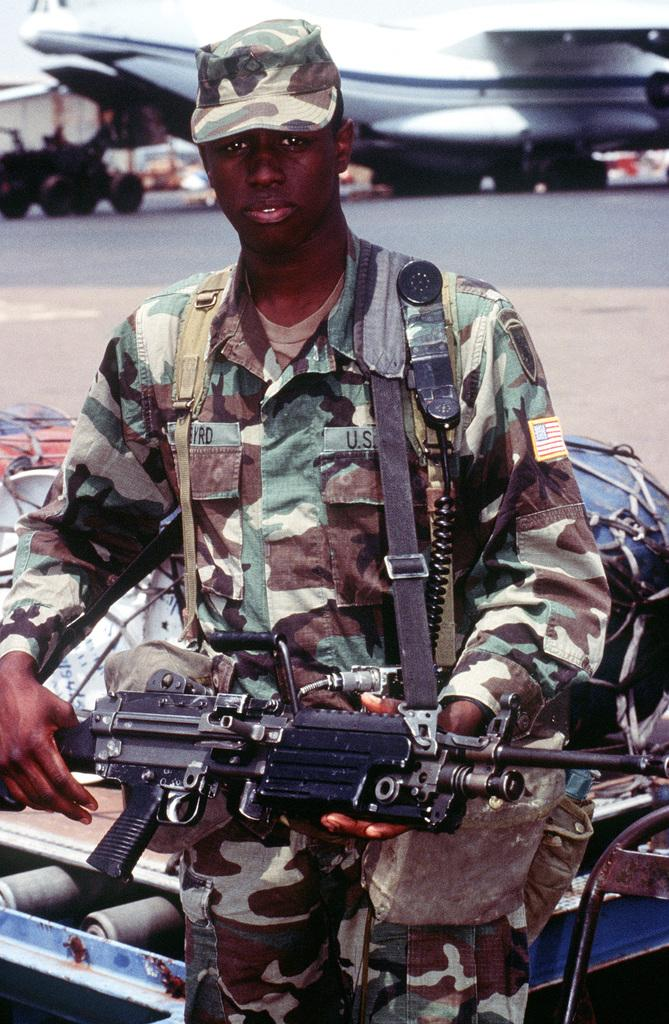What is the main subject of the image? There is a soldier in the image. What is the soldier holding in the image? The soldier is holding a gun. What is the soldier's posture in the image? The soldier is standing. What can be seen behind the soldier in the image? There are objects behind the soldier. What type of vehicles can be seen in the background of the image? There is an aircraft and another vehicle in the background of the image. What is the title of the book the soldier is reading in the image? There is no book present in the image, so there is no title to reference. Can you tell me how many chess pieces are on the board in the image? There is no chessboard present in the image, so it is not possible to determine the number of chess pieces. 